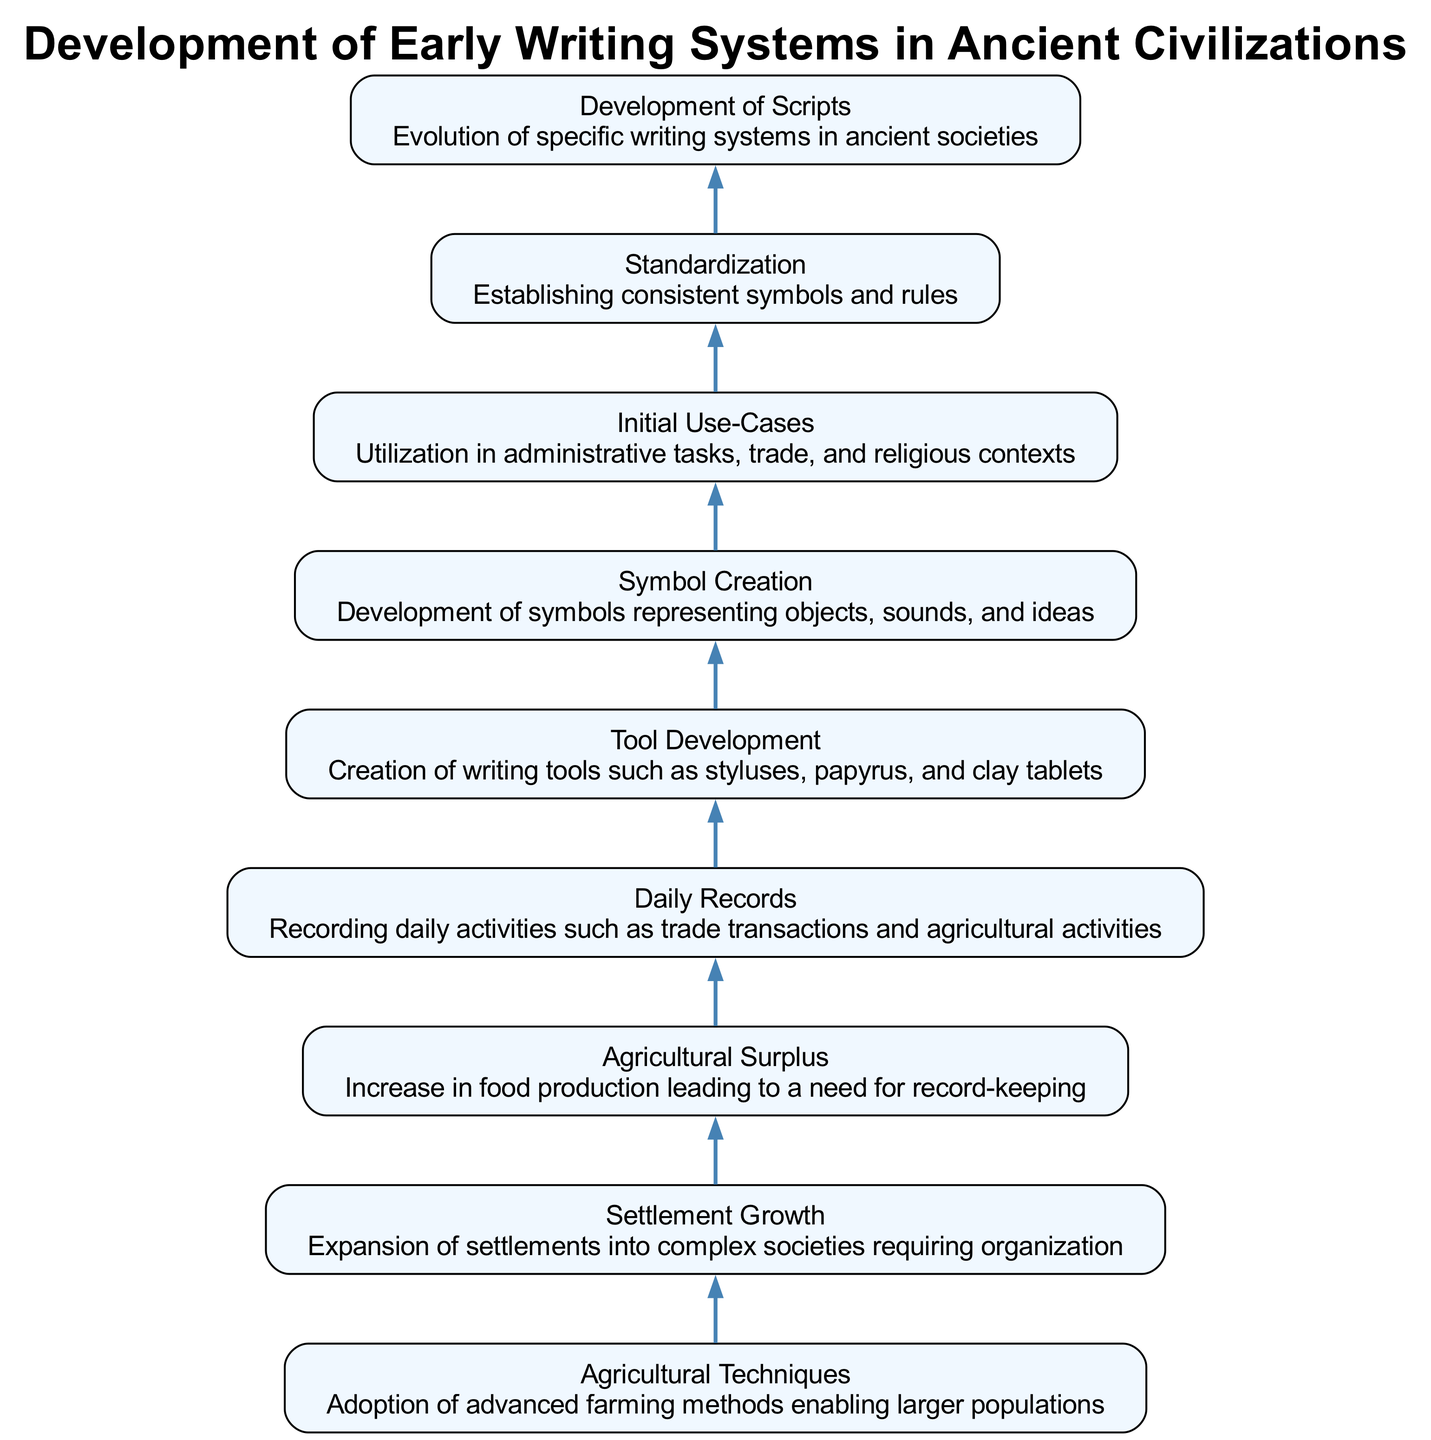What is the top node of the diagram? The top node is "Development of Scripts," which indicates the final output of the flowchart process, showing the evolutionary endpoint of early writing systems.
Answer: Development of Scripts How many nodes are present in the diagram? The diagram includes a total of eight nodes, each representing a key step in the development of early writing systems in ancient civilizations.
Answer: Eight What comes after "Standardization" in the flow chart? After "Standardization," the next step is "Development of Scripts," which signifies the evolution of specific writing systems as a culmination of standardized symbols.
Answer: Development of Scripts Which node directly precedes "Daily Records"? "Tool Development" directly precedes "Daily Records," indicating that the creation of writing tools was essential before recording daily activities.
Answer: Tool Development What is the relationship between "Agricultural Surplus" and "Settlement Growth"? "Agricultural Surplus" leads to "Settlement Growth," showing that increased food production necessitated more complex societal structures and organization.
Answer: Agricultural Surplus leads to Settlement Growth How does "Symbol Creation" relate to "Daily Records"? "Symbol Creation" leads to "Initial Use-Cases," and "Daily Records" stems from "Initial Use-Cases," indicating that the development of symbols was foundational for recording daily activities.
Answer: Symbol Creation → Initial Use-Cases → Daily Records What is the main purpose of "Initial Use-Cases"? The main purpose of "Initial Use-Cases" is to utilize writing in administrative tasks, trade, and religious contexts, showcasing the practical applications of early writing.
Answer: Administrative tasks, trade, and religious contexts In terms of flow direction, how does the process signify the evolution of writing systems? The flow direction from "Agricultural Techniques" through various stages to "Development of Scripts" illustrates a progression from basic agricultural methods to advanced writing systems, highlighting the interdependencies of societal developments.
Answer: From Agricultural Techniques to Development of Scripts 